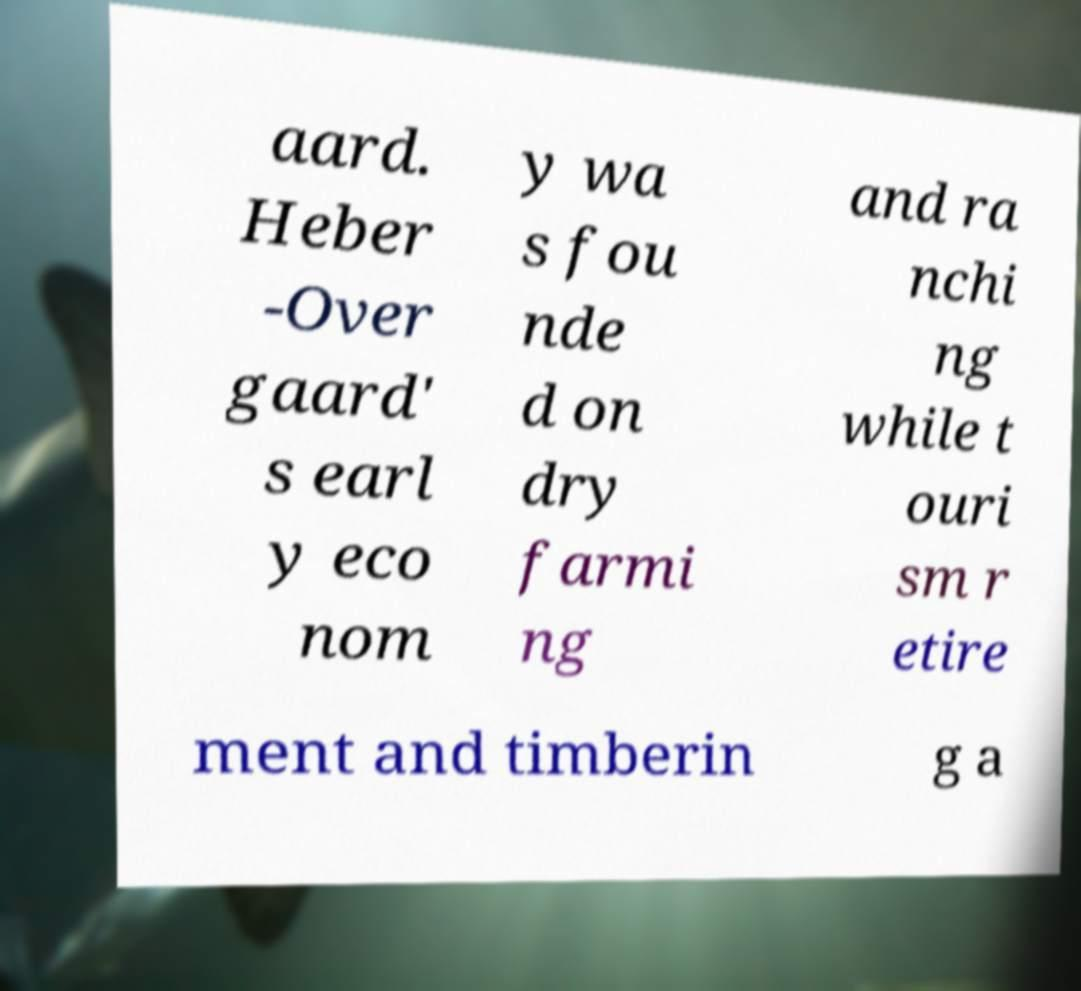Can you accurately transcribe the text from the provided image for me? aard. Heber -Over gaard' s earl y eco nom y wa s fou nde d on dry farmi ng and ra nchi ng while t ouri sm r etire ment and timberin g a 